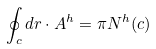<formula> <loc_0><loc_0><loc_500><loc_500>\oint \nolimits _ { c } d r \cdot A ^ { h } = \pi N ^ { h } ( c )</formula> 